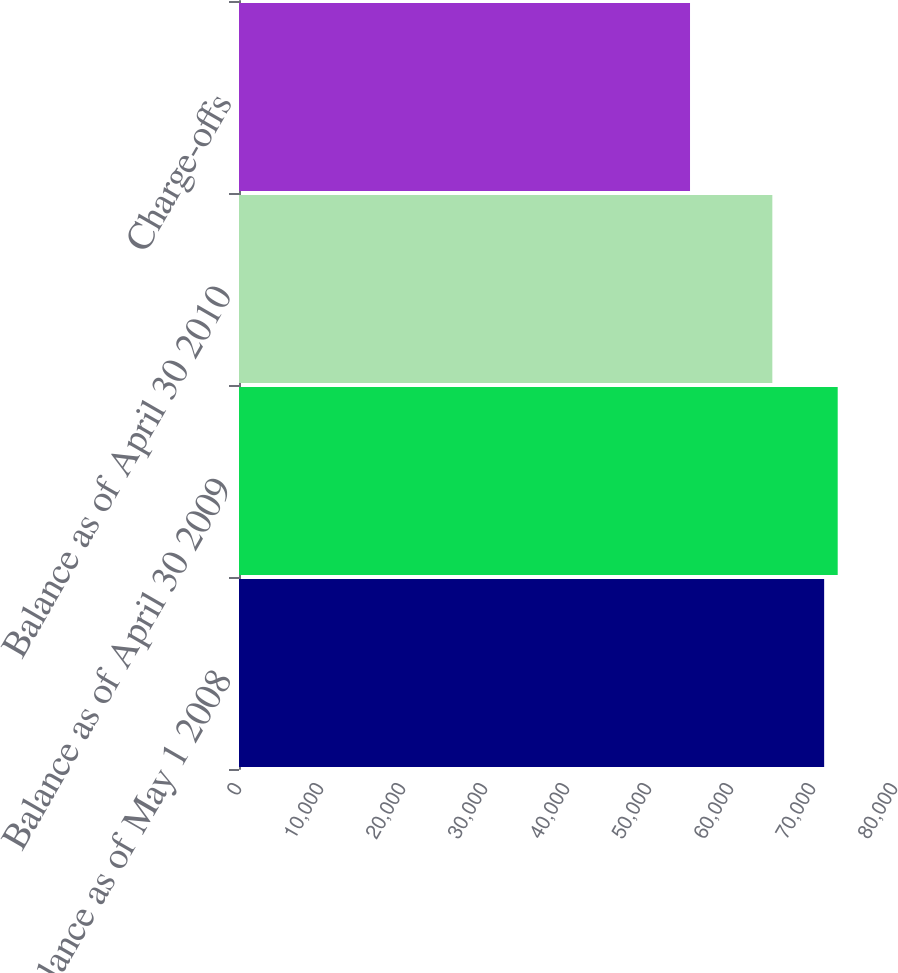Convert chart. <chart><loc_0><loc_0><loc_500><loc_500><bar_chart><fcel>Balance as of May 1 2008<fcel>Balance as of April 30 2009<fcel>Balance as of April 30 2010<fcel>Charge-offs<nl><fcel>71360<fcel>73012.3<fcel>65041<fcel>55003<nl></chart> 